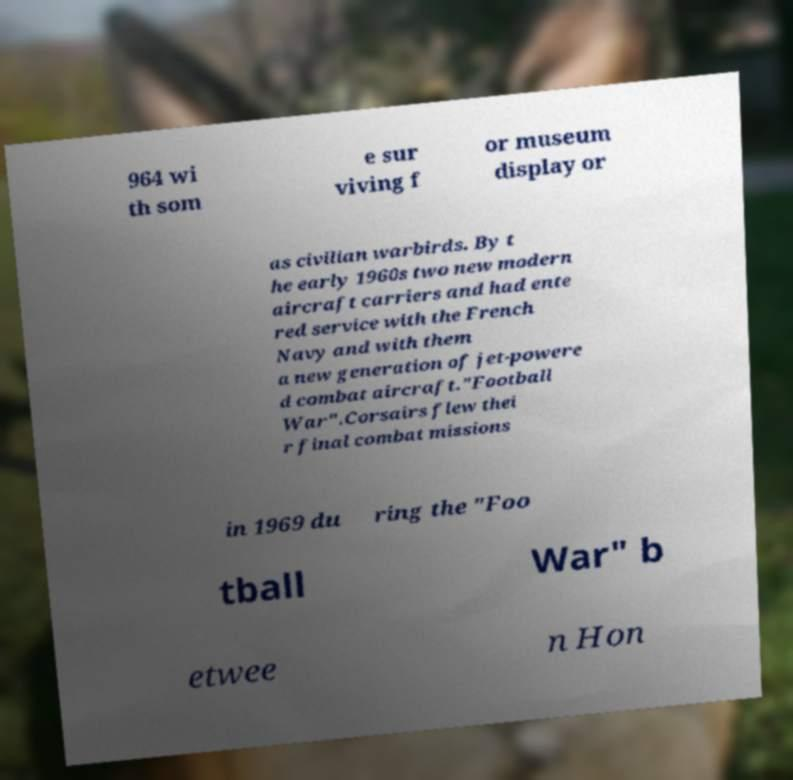What messages or text are displayed in this image? I need them in a readable, typed format. 964 wi th som e sur viving f or museum display or as civilian warbirds. By t he early 1960s two new modern aircraft carriers and had ente red service with the French Navy and with them a new generation of jet-powere d combat aircraft."Football War".Corsairs flew thei r final combat missions in 1969 du ring the "Foo tball War" b etwee n Hon 